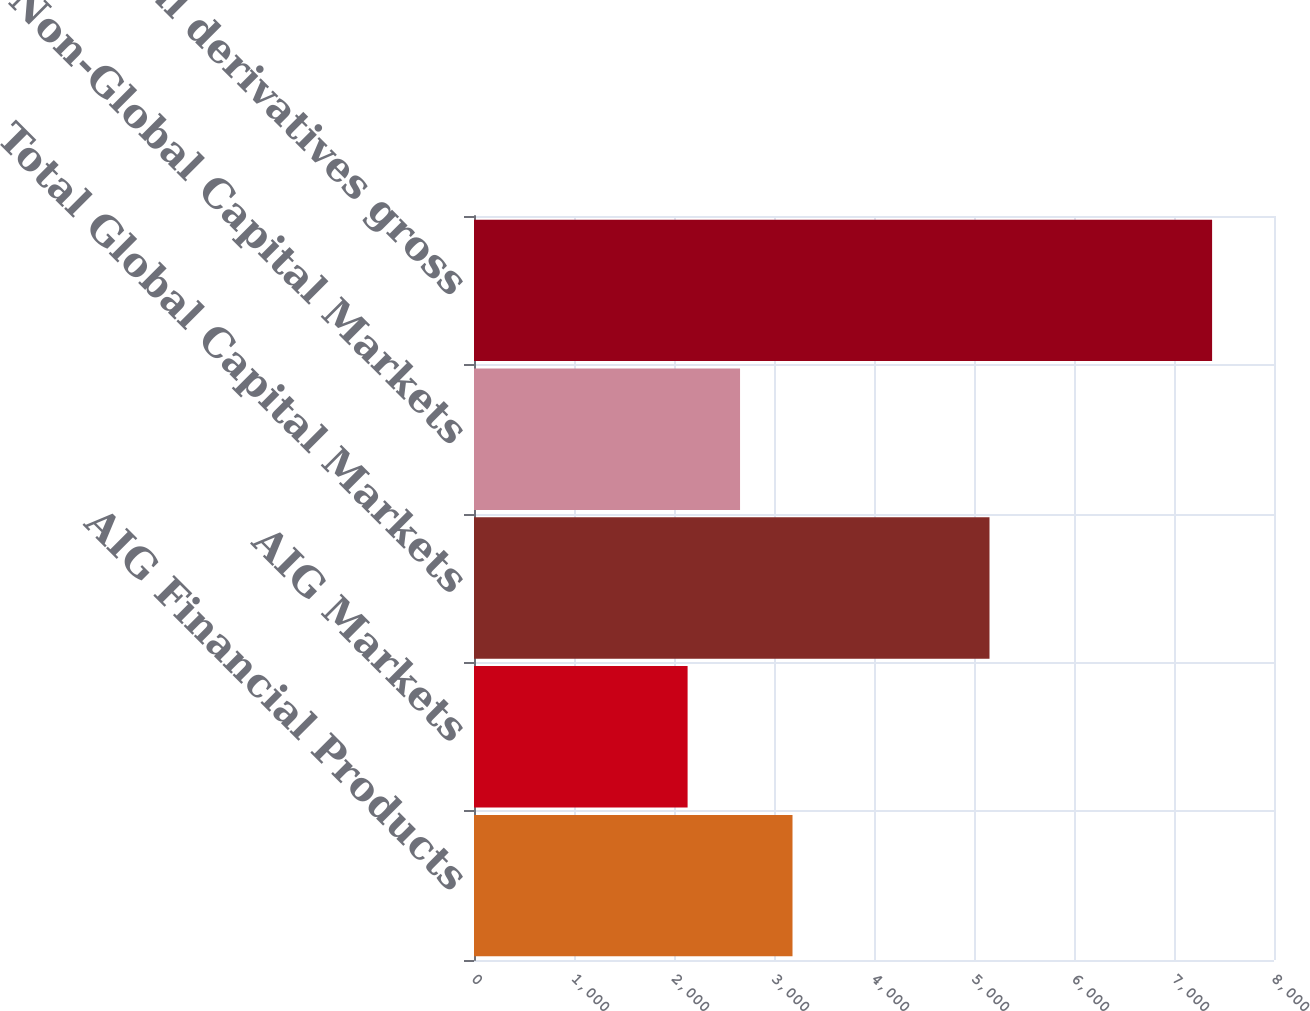Convert chart to OTSL. <chart><loc_0><loc_0><loc_500><loc_500><bar_chart><fcel>AIG Financial Products<fcel>AIG Markets<fcel>Total Global Capital Markets<fcel>Non-Global Capital Markets<fcel>Total derivatives gross<nl><fcel>3185<fcel>2136<fcel>5155<fcel>2660.5<fcel>7381<nl></chart> 